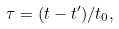Convert formula to latex. <formula><loc_0><loc_0><loc_500><loc_500>\tau = ( t - t ^ { \prime } ) / t _ { 0 } ,</formula> 